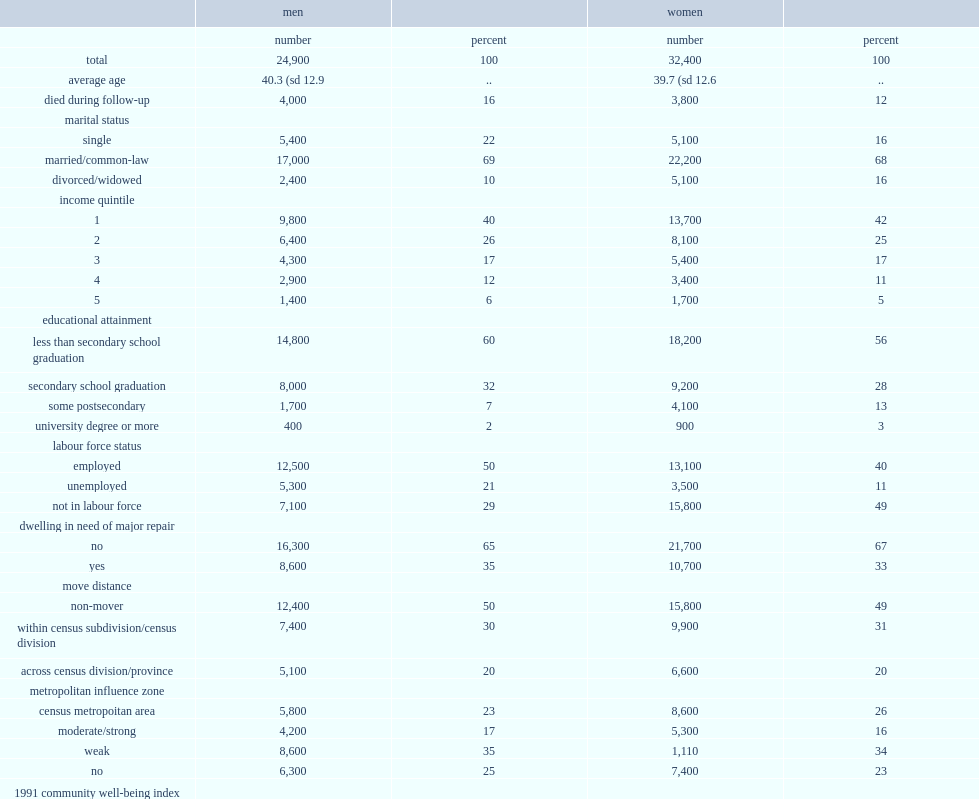What are the average ages of registered first nations cohort members for men and women respectively? 40.3 (sd 12.9 39.7 (sd 12.6. What are the death rates for men and women by the end of the follow-up period (december 31, 2006),respectively? 16 12. Which group of people was less likely to be divorced or widowed? Men. Which group of people was more likely to be single? Men. How many percent of registered first nations cohort members were in the highest income quintile? 0.054291. How many percent of registered first nations cohort members were in the lowest income quintile? 0.411559. What percentages of men and women, respectively, were not secondary school graduates? 60 56. What are the employed rate and unemployed rate for men respectively? 50 21. What are the employed rate and unemployed rate for women respectively? 40 11. Which group of people is more likely not to be in the labour force? Women. About three-quarters of cohort members lived in crowded dwelling, what fraction of cohort members was in dwellings that needed major repairs? 0.663176. By the end of follow-up, how many percent of registered first nations cohort members had moved within a census division? 0.302448. How many percent of registered first nations cohort members had moved from one census division or province/territory to another? 0.204545. 